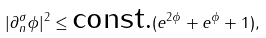Convert formula to latex. <formula><loc_0><loc_0><loc_500><loc_500>| \partial _ { n } ^ { \sigma } \phi | ^ { 2 } \leq \text {const.} ( e ^ { 2 \phi } + e ^ { \phi } + 1 ) ,</formula> 